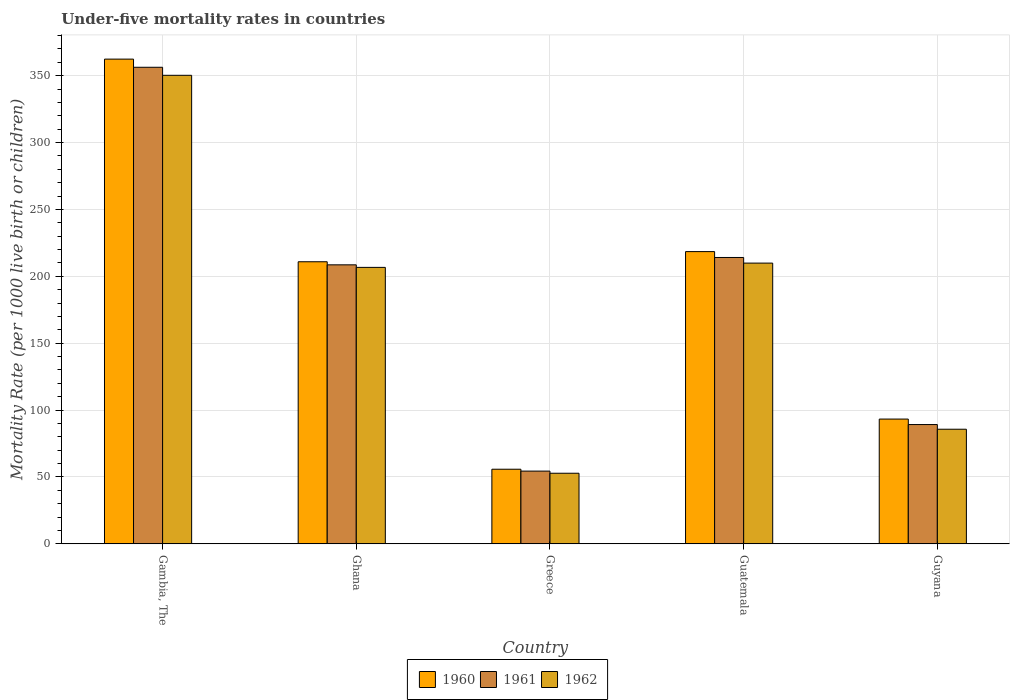Are the number of bars per tick equal to the number of legend labels?
Provide a short and direct response. Yes. Are the number of bars on each tick of the X-axis equal?
Ensure brevity in your answer.  Yes. How many bars are there on the 1st tick from the left?
Ensure brevity in your answer.  3. How many bars are there on the 2nd tick from the right?
Give a very brief answer. 3. In how many cases, is the number of bars for a given country not equal to the number of legend labels?
Your answer should be compact. 0. What is the under-five mortality rate in 1962 in Gambia, The?
Your response must be concise. 350.3. Across all countries, what is the maximum under-five mortality rate in 1961?
Your response must be concise. 356.3. Across all countries, what is the minimum under-five mortality rate in 1961?
Offer a terse response. 54.4. In which country was the under-five mortality rate in 1960 maximum?
Offer a very short reply. Gambia, The. In which country was the under-five mortality rate in 1962 minimum?
Your answer should be compact. Greece. What is the total under-five mortality rate in 1960 in the graph?
Provide a succinct answer. 940.9. What is the difference between the under-five mortality rate in 1960 in Ghana and that in Guyana?
Offer a terse response. 117.6. What is the difference between the under-five mortality rate in 1962 in Greece and the under-five mortality rate in 1961 in Guatemala?
Your answer should be very brief. -161.3. What is the average under-five mortality rate in 1962 per country?
Give a very brief answer. 181.08. What is the difference between the under-five mortality rate of/in 1960 and under-five mortality rate of/in 1962 in Ghana?
Provide a short and direct response. 4.2. What is the ratio of the under-five mortality rate in 1962 in Ghana to that in Guatemala?
Keep it short and to the point. 0.98. Is the under-five mortality rate in 1960 in Ghana less than that in Guatemala?
Your answer should be very brief. Yes. Is the difference between the under-five mortality rate in 1960 in Greece and Guatemala greater than the difference between the under-five mortality rate in 1962 in Greece and Guatemala?
Provide a succinct answer. No. What is the difference between the highest and the second highest under-five mortality rate in 1962?
Offer a terse response. 3.2. What is the difference between the highest and the lowest under-five mortality rate in 1960?
Give a very brief answer. 306.6. What does the 2nd bar from the left in Gambia, The represents?
Offer a very short reply. 1961. How many bars are there?
Ensure brevity in your answer.  15. Are the values on the major ticks of Y-axis written in scientific E-notation?
Give a very brief answer. No. Where does the legend appear in the graph?
Provide a short and direct response. Bottom center. How are the legend labels stacked?
Provide a short and direct response. Horizontal. What is the title of the graph?
Give a very brief answer. Under-five mortality rates in countries. What is the label or title of the Y-axis?
Offer a very short reply. Mortality Rate (per 1000 live birth or children). What is the Mortality Rate (per 1000 live birth or children) of 1960 in Gambia, The?
Offer a very short reply. 362.4. What is the Mortality Rate (per 1000 live birth or children) of 1961 in Gambia, The?
Provide a short and direct response. 356.3. What is the Mortality Rate (per 1000 live birth or children) in 1962 in Gambia, The?
Provide a succinct answer. 350.3. What is the Mortality Rate (per 1000 live birth or children) of 1960 in Ghana?
Offer a terse response. 210.9. What is the Mortality Rate (per 1000 live birth or children) in 1961 in Ghana?
Your answer should be compact. 208.6. What is the Mortality Rate (per 1000 live birth or children) in 1962 in Ghana?
Your answer should be compact. 206.7. What is the Mortality Rate (per 1000 live birth or children) in 1960 in Greece?
Make the answer very short. 55.8. What is the Mortality Rate (per 1000 live birth or children) of 1961 in Greece?
Make the answer very short. 54.4. What is the Mortality Rate (per 1000 live birth or children) in 1962 in Greece?
Your answer should be compact. 52.8. What is the Mortality Rate (per 1000 live birth or children) of 1960 in Guatemala?
Your answer should be very brief. 218.5. What is the Mortality Rate (per 1000 live birth or children) in 1961 in Guatemala?
Your answer should be compact. 214.1. What is the Mortality Rate (per 1000 live birth or children) in 1962 in Guatemala?
Give a very brief answer. 209.9. What is the Mortality Rate (per 1000 live birth or children) in 1960 in Guyana?
Your answer should be compact. 93.3. What is the Mortality Rate (per 1000 live birth or children) of 1961 in Guyana?
Offer a very short reply. 89.2. What is the Mortality Rate (per 1000 live birth or children) in 1962 in Guyana?
Keep it short and to the point. 85.7. Across all countries, what is the maximum Mortality Rate (per 1000 live birth or children) in 1960?
Provide a succinct answer. 362.4. Across all countries, what is the maximum Mortality Rate (per 1000 live birth or children) of 1961?
Offer a very short reply. 356.3. Across all countries, what is the maximum Mortality Rate (per 1000 live birth or children) of 1962?
Make the answer very short. 350.3. Across all countries, what is the minimum Mortality Rate (per 1000 live birth or children) in 1960?
Give a very brief answer. 55.8. Across all countries, what is the minimum Mortality Rate (per 1000 live birth or children) of 1961?
Your response must be concise. 54.4. Across all countries, what is the minimum Mortality Rate (per 1000 live birth or children) in 1962?
Your answer should be very brief. 52.8. What is the total Mortality Rate (per 1000 live birth or children) in 1960 in the graph?
Offer a terse response. 940.9. What is the total Mortality Rate (per 1000 live birth or children) of 1961 in the graph?
Offer a very short reply. 922.6. What is the total Mortality Rate (per 1000 live birth or children) in 1962 in the graph?
Your response must be concise. 905.4. What is the difference between the Mortality Rate (per 1000 live birth or children) in 1960 in Gambia, The and that in Ghana?
Your answer should be compact. 151.5. What is the difference between the Mortality Rate (per 1000 live birth or children) in 1961 in Gambia, The and that in Ghana?
Ensure brevity in your answer.  147.7. What is the difference between the Mortality Rate (per 1000 live birth or children) of 1962 in Gambia, The and that in Ghana?
Ensure brevity in your answer.  143.6. What is the difference between the Mortality Rate (per 1000 live birth or children) in 1960 in Gambia, The and that in Greece?
Your answer should be compact. 306.6. What is the difference between the Mortality Rate (per 1000 live birth or children) of 1961 in Gambia, The and that in Greece?
Provide a short and direct response. 301.9. What is the difference between the Mortality Rate (per 1000 live birth or children) of 1962 in Gambia, The and that in Greece?
Your response must be concise. 297.5. What is the difference between the Mortality Rate (per 1000 live birth or children) of 1960 in Gambia, The and that in Guatemala?
Your response must be concise. 143.9. What is the difference between the Mortality Rate (per 1000 live birth or children) of 1961 in Gambia, The and that in Guatemala?
Give a very brief answer. 142.2. What is the difference between the Mortality Rate (per 1000 live birth or children) in 1962 in Gambia, The and that in Guatemala?
Provide a succinct answer. 140.4. What is the difference between the Mortality Rate (per 1000 live birth or children) in 1960 in Gambia, The and that in Guyana?
Give a very brief answer. 269.1. What is the difference between the Mortality Rate (per 1000 live birth or children) of 1961 in Gambia, The and that in Guyana?
Ensure brevity in your answer.  267.1. What is the difference between the Mortality Rate (per 1000 live birth or children) in 1962 in Gambia, The and that in Guyana?
Offer a terse response. 264.6. What is the difference between the Mortality Rate (per 1000 live birth or children) in 1960 in Ghana and that in Greece?
Ensure brevity in your answer.  155.1. What is the difference between the Mortality Rate (per 1000 live birth or children) of 1961 in Ghana and that in Greece?
Provide a succinct answer. 154.2. What is the difference between the Mortality Rate (per 1000 live birth or children) in 1962 in Ghana and that in Greece?
Provide a succinct answer. 153.9. What is the difference between the Mortality Rate (per 1000 live birth or children) of 1960 in Ghana and that in Guyana?
Your answer should be compact. 117.6. What is the difference between the Mortality Rate (per 1000 live birth or children) in 1961 in Ghana and that in Guyana?
Make the answer very short. 119.4. What is the difference between the Mortality Rate (per 1000 live birth or children) in 1962 in Ghana and that in Guyana?
Offer a terse response. 121. What is the difference between the Mortality Rate (per 1000 live birth or children) in 1960 in Greece and that in Guatemala?
Your answer should be compact. -162.7. What is the difference between the Mortality Rate (per 1000 live birth or children) in 1961 in Greece and that in Guatemala?
Keep it short and to the point. -159.7. What is the difference between the Mortality Rate (per 1000 live birth or children) in 1962 in Greece and that in Guatemala?
Offer a very short reply. -157.1. What is the difference between the Mortality Rate (per 1000 live birth or children) in 1960 in Greece and that in Guyana?
Offer a terse response. -37.5. What is the difference between the Mortality Rate (per 1000 live birth or children) in 1961 in Greece and that in Guyana?
Give a very brief answer. -34.8. What is the difference between the Mortality Rate (per 1000 live birth or children) in 1962 in Greece and that in Guyana?
Offer a very short reply. -32.9. What is the difference between the Mortality Rate (per 1000 live birth or children) of 1960 in Guatemala and that in Guyana?
Provide a succinct answer. 125.2. What is the difference between the Mortality Rate (per 1000 live birth or children) of 1961 in Guatemala and that in Guyana?
Offer a terse response. 124.9. What is the difference between the Mortality Rate (per 1000 live birth or children) of 1962 in Guatemala and that in Guyana?
Your answer should be compact. 124.2. What is the difference between the Mortality Rate (per 1000 live birth or children) of 1960 in Gambia, The and the Mortality Rate (per 1000 live birth or children) of 1961 in Ghana?
Offer a very short reply. 153.8. What is the difference between the Mortality Rate (per 1000 live birth or children) of 1960 in Gambia, The and the Mortality Rate (per 1000 live birth or children) of 1962 in Ghana?
Make the answer very short. 155.7. What is the difference between the Mortality Rate (per 1000 live birth or children) of 1961 in Gambia, The and the Mortality Rate (per 1000 live birth or children) of 1962 in Ghana?
Offer a very short reply. 149.6. What is the difference between the Mortality Rate (per 1000 live birth or children) in 1960 in Gambia, The and the Mortality Rate (per 1000 live birth or children) in 1961 in Greece?
Your answer should be very brief. 308. What is the difference between the Mortality Rate (per 1000 live birth or children) of 1960 in Gambia, The and the Mortality Rate (per 1000 live birth or children) of 1962 in Greece?
Your answer should be compact. 309.6. What is the difference between the Mortality Rate (per 1000 live birth or children) in 1961 in Gambia, The and the Mortality Rate (per 1000 live birth or children) in 1962 in Greece?
Ensure brevity in your answer.  303.5. What is the difference between the Mortality Rate (per 1000 live birth or children) of 1960 in Gambia, The and the Mortality Rate (per 1000 live birth or children) of 1961 in Guatemala?
Your response must be concise. 148.3. What is the difference between the Mortality Rate (per 1000 live birth or children) of 1960 in Gambia, The and the Mortality Rate (per 1000 live birth or children) of 1962 in Guatemala?
Provide a short and direct response. 152.5. What is the difference between the Mortality Rate (per 1000 live birth or children) in 1961 in Gambia, The and the Mortality Rate (per 1000 live birth or children) in 1962 in Guatemala?
Keep it short and to the point. 146.4. What is the difference between the Mortality Rate (per 1000 live birth or children) of 1960 in Gambia, The and the Mortality Rate (per 1000 live birth or children) of 1961 in Guyana?
Your answer should be compact. 273.2. What is the difference between the Mortality Rate (per 1000 live birth or children) in 1960 in Gambia, The and the Mortality Rate (per 1000 live birth or children) in 1962 in Guyana?
Provide a short and direct response. 276.7. What is the difference between the Mortality Rate (per 1000 live birth or children) of 1961 in Gambia, The and the Mortality Rate (per 1000 live birth or children) of 1962 in Guyana?
Provide a succinct answer. 270.6. What is the difference between the Mortality Rate (per 1000 live birth or children) of 1960 in Ghana and the Mortality Rate (per 1000 live birth or children) of 1961 in Greece?
Your answer should be compact. 156.5. What is the difference between the Mortality Rate (per 1000 live birth or children) in 1960 in Ghana and the Mortality Rate (per 1000 live birth or children) in 1962 in Greece?
Your answer should be very brief. 158.1. What is the difference between the Mortality Rate (per 1000 live birth or children) of 1961 in Ghana and the Mortality Rate (per 1000 live birth or children) of 1962 in Greece?
Give a very brief answer. 155.8. What is the difference between the Mortality Rate (per 1000 live birth or children) of 1960 in Ghana and the Mortality Rate (per 1000 live birth or children) of 1961 in Guatemala?
Ensure brevity in your answer.  -3.2. What is the difference between the Mortality Rate (per 1000 live birth or children) of 1961 in Ghana and the Mortality Rate (per 1000 live birth or children) of 1962 in Guatemala?
Your answer should be very brief. -1.3. What is the difference between the Mortality Rate (per 1000 live birth or children) of 1960 in Ghana and the Mortality Rate (per 1000 live birth or children) of 1961 in Guyana?
Your answer should be very brief. 121.7. What is the difference between the Mortality Rate (per 1000 live birth or children) in 1960 in Ghana and the Mortality Rate (per 1000 live birth or children) in 1962 in Guyana?
Your answer should be very brief. 125.2. What is the difference between the Mortality Rate (per 1000 live birth or children) of 1961 in Ghana and the Mortality Rate (per 1000 live birth or children) of 1962 in Guyana?
Your answer should be very brief. 122.9. What is the difference between the Mortality Rate (per 1000 live birth or children) in 1960 in Greece and the Mortality Rate (per 1000 live birth or children) in 1961 in Guatemala?
Provide a succinct answer. -158.3. What is the difference between the Mortality Rate (per 1000 live birth or children) in 1960 in Greece and the Mortality Rate (per 1000 live birth or children) in 1962 in Guatemala?
Offer a terse response. -154.1. What is the difference between the Mortality Rate (per 1000 live birth or children) of 1961 in Greece and the Mortality Rate (per 1000 live birth or children) of 1962 in Guatemala?
Offer a terse response. -155.5. What is the difference between the Mortality Rate (per 1000 live birth or children) in 1960 in Greece and the Mortality Rate (per 1000 live birth or children) in 1961 in Guyana?
Ensure brevity in your answer.  -33.4. What is the difference between the Mortality Rate (per 1000 live birth or children) in 1960 in Greece and the Mortality Rate (per 1000 live birth or children) in 1962 in Guyana?
Ensure brevity in your answer.  -29.9. What is the difference between the Mortality Rate (per 1000 live birth or children) of 1961 in Greece and the Mortality Rate (per 1000 live birth or children) of 1962 in Guyana?
Your answer should be very brief. -31.3. What is the difference between the Mortality Rate (per 1000 live birth or children) in 1960 in Guatemala and the Mortality Rate (per 1000 live birth or children) in 1961 in Guyana?
Your answer should be very brief. 129.3. What is the difference between the Mortality Rate (per 1000 live birth or children) of 1960 in Guatemala and the Mortality Rate (per 1000 live birth or children) of 1962 in Guyana?
Offer a very short reply. 132.8. What is the difference between the Mortality Rate (per 1000 live birth or children) of 1961 in Guatemala and the Mortality Rate (per 1000 live birth or children) of 1962 in Guyana?
Offer a very short reply. 128.4. What is the average Mortality Rate (per 1000 live birth or children) of 1960 per country?
Ensure brevity in your answer.  188.18. What is the average Mortality Rate (per 1000 live birth or children) of 1961 per country?
Provide a short and direct response. 184.52. What is the average Mortality Rate (per 1000 live birth or children) in 1962 per country?
Provide a short and direct response. 181.08. What is the difference between the Mortality Rate (per 1000 live birth or children) of 1960 and Mortality Rate (per 1000 live birth or children) of 1962 in Gambia, The?
Keep it short and to the point. 12.1. What is the difference between the Mortality Rate (per 1000 live birth or children) in 1960 and Mortality Rate (per 1000 live birth or children) in 1961 in Ghana?
Make the answer very short. 2.3. What is the difference between the Mortality Rate (per 1000 live birth or children) in 1960 and Mortality Rate (per 1000 live birth or children) in 1962 in Ghana?
Ensure brevity in your answer.  4.2. What is the difference between the Mortality Rate (per 1000 live birth or children) in 1961 and Mortality Rate (per 1000 live birth or children) in 1962 in Greece?
Ensure brevity in your answer.  1.6. What is the difference between the Mortality Rate (per 1000 live birth or children) of 1960 and Mortality Rate (per 1000 live birth or children) of 1961 in Guatemala?
Your answer should be very brief. 4.4. What is the difference between the Mortality Rate (per 1000 live birth or children) of 1960 and Mortality Rate (per 1000 live birth or children) of 1962 in Guatemala?
Give a very brief answer. 8.6. What is the difference between the Mortality Rate (per 1000 live birth or children) in 1960 and Mortality Rate (per 1000 live birth or children) in 1961 in Guyana?
Keep it short and to the point. 4.1. What is the ratio of the Mortality Rate (per 1000 live birth or children) in 1960 in Gambia, The to that in Ghana?
Provide a succinct answer. 1.72. What is the ratio of the Mortality Rate (per 1000 live birth or children) of 1961 in Gambia, The to that in Ghana?
Ensure brevity in your answer.  1.71. What is the ratio of the Mortality Rate (per 1000 live birth or children) of 1962 in Gambia, The to that in Ghana?
Keep it short and to the point. 1.69. What is the ratio of the Mortality Rate (per 1000 live birth or children) in 1960 in Gambia, The to that in Greece?
Your answer should be very brief. 6.49. What is the ratio of the Mortality Rate (per 1000 live birth or children) in 1961 in Gambia, The to that in Greece?
Ensure brevity in your answer.  6.55. What is the ratio of the Mortality Rate (per 1000 live birth or children) of 1962 in Gambia, The to that in Greece?
Your response must be concise. 6.63. What is the ratio of the Mortality Rate (per 1000 live birth or children) in 1960 in Gambia, The to that in Guatemala?
Keep it short and to the point. 1.66. What is the ratio of the Mortality Rate (per 1000 live birth or children) in 1961 in Gambia, The to that in Guatemala?
Give a very brief answer. 1.66. What is the ratio of the Mortality Rate (per 1000 live birth or children) of 1962 in Gambia, The to that in Guatemala?
Offer a terse response. 1.67. What is the ratio of the Mortality Rate (per 1000 live birth or children) of 1960 in Gambia, The to that in Guyana?
Make the answer very short. 3.88. What is the ratio of the Mortality Rate (per 1000 live birth or children) in 1961 in Gambia, The to that in Guyana?
Offer a terse response. 3.99. What is the ratio of the Mortality Rate (per 1000 live birth or children) of 1962 in Gambia, The to that in Guyana?
Make the answer very short. 4.09. What is the ratio of the Mortality Rate (per 1000 live birth or children) in 1960 in Ghana to that in Greece?
Keep it short and to the point. 3.78. What is the ratio of the Mortality Rate (per 1000 live birth or children) in 1961 in Ghana to that in Greece?
Make the answer very short. 3.83. What is the ratio of the Mortality Rate (per 1000 live birth or children) of 1962 in Ghana to that in Greece?
Provide a short and direct response. 3.91. What is the ratio of the Mortality Rate (per 1000 live birth or children) of 1960 in Ghana to that in Guatemala?
Provide a short and direct response. 0.97. What is the ratio of the Mortality Rate (per 1000 live birth or children) of 1961 in Ghana to that in Guatemala?
Make the answer very short. 0.97. What is the ratio of the Mortality Rate (per 1000 live birth or children) in 1962 in Ghana to that in Guatemala?
Your response must be concise. 0.98. What is the ratio of the Mortality Rate (per 1000 live birth or children) in 1960 in Ghana to that in Guyana?
Your response must be concise. 2.26. What is the ratio of the Mortality Rate (per 1000 live birth or children) of 1961 in Ghana to that in Guyana?
Your answer should be compact. 2.34. What is the ratio of the Mortality Rate (per 1000 live birth or children) in 1962 in Ghana to that in Guyana?
Make the answer very short. 2.41. What is the ratio of the Mortality Rate (per 1000 live birth or children) of 1960 in Greece to that in Guatemala?
Ensure brevity in your answer.  0.26. What is the ratio of the Mortality Rate (per 1000 live birth or children) in 1961 in Greece to that in Guatemala?
Offer a terse response. 0.25. What is the ratio of the Mortality Rate (per 1000 live birth or children) in 1962 in Greece to that in Guatemala?
Your response must be concise. 0.25. What is the ratio of the Mortality Rate (per 1000 live birth or children) in 1960 in Greece to that in Guyana?
Give a very brief answer. 0.6. What is the ratio of the Mortality Rate (per 1000 live birth or children) in 1961 in Greece to that in Guyana?
Provide a short and direct response. 0.61. What is the ratio of the Mortality Rate (per 1000 live birth or children) in 1962 in Greece to that in Guyana?
Ensure brevity in your answer.  0.62. What is the ratio of the Mortality Rate (per 1000 live birth or children) in 1960 in Guatemala to that in Guyana?
Give a very brief answer. 2.34. What is the ratio of the Mortality Rate (per 1000 live birth or children) of 1961 in Guatemala to that in Guyana?
Your answer should be compact. 2.4. What is the ratio of the Mortality Rate (per 1000 live birth or children) in 1962 in Guatemala to that in Guyana?
Your answer should be very brief. 2.45. What is the difference between the highest and the second highest Mortality Rate (per 1000 live birth or children) in 1960?
Your answer should be very brief. 143.9. What is the difference between the highest and the second highest Mortality Rate (per 1000 live birth or children) in 1961?
Your answer should be very brief. 142.2. What is the difference between the highest and the second highest Mortality Rate (per 1000 live birth or children) in 1962?
Ensure brevity in your answer.  140.4. What is the difference between the highest and the lowest Mortality Rate (per 1000 live birth or children) of 1960?
Keep it short and to the point. 306.6. What is the difference between the highest and the lowest Mortality Rate (per 1000 live birth or children) of 1961?
Your answer should be very brief. 301.9. What is the difference between the highest and the lowest Mortality Rate (per 1000 live birth or children) of 1962?
Provide a short and direct response. 297.5. 